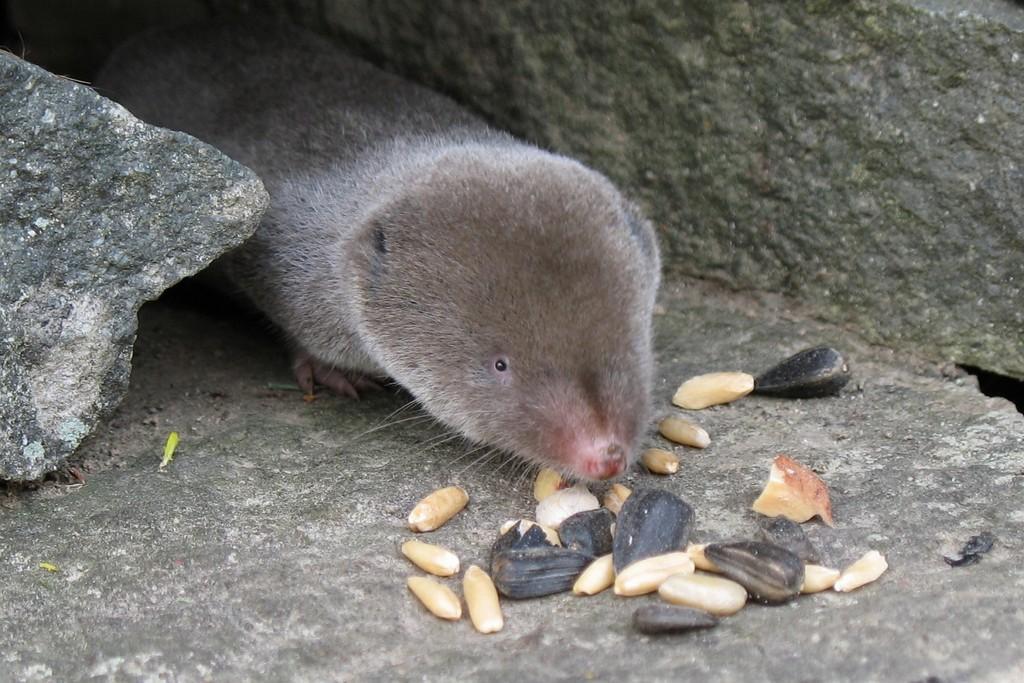Could you give a brief overview of what you see in this image? In this picture we can see mold in the image. In the front bottom side there are some black seeds. Behind we can see stones. 